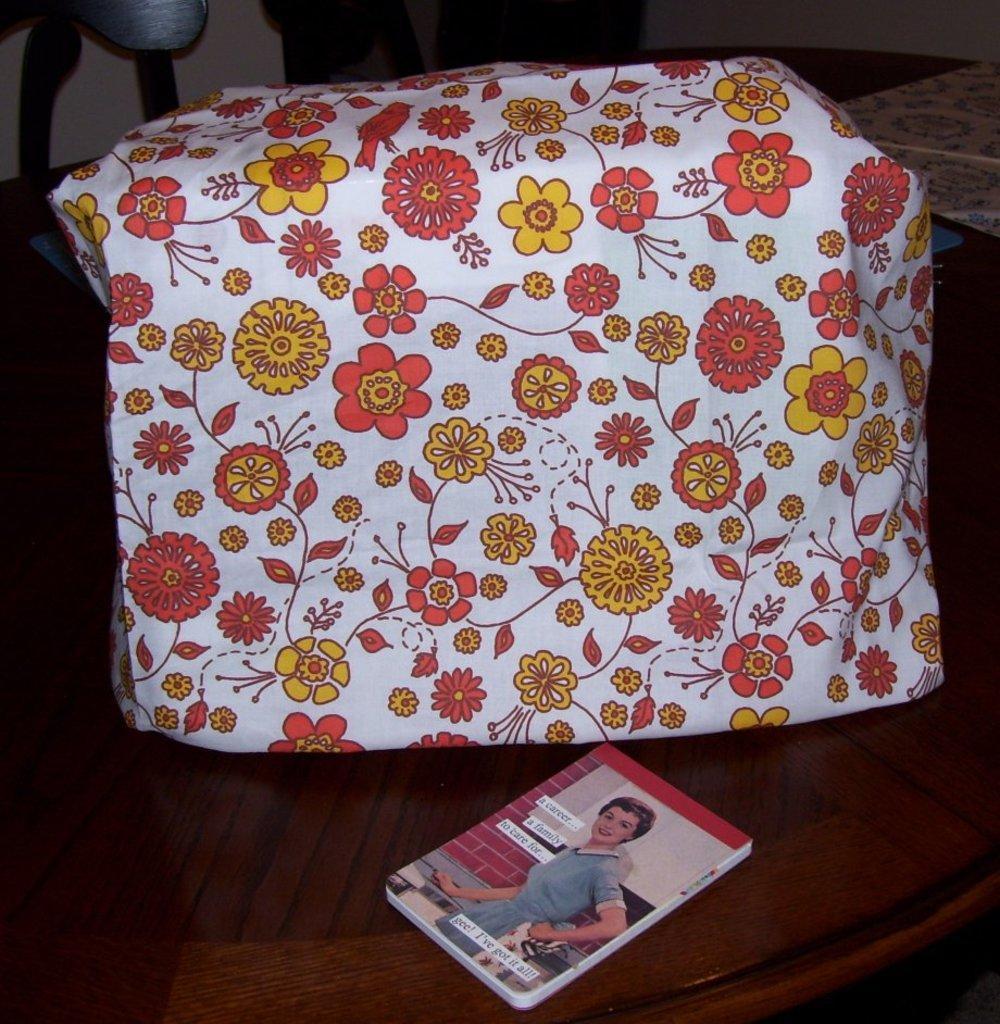In one or two sentences, can you explain what this image depicts? In this image, there is table contains a book and package. 